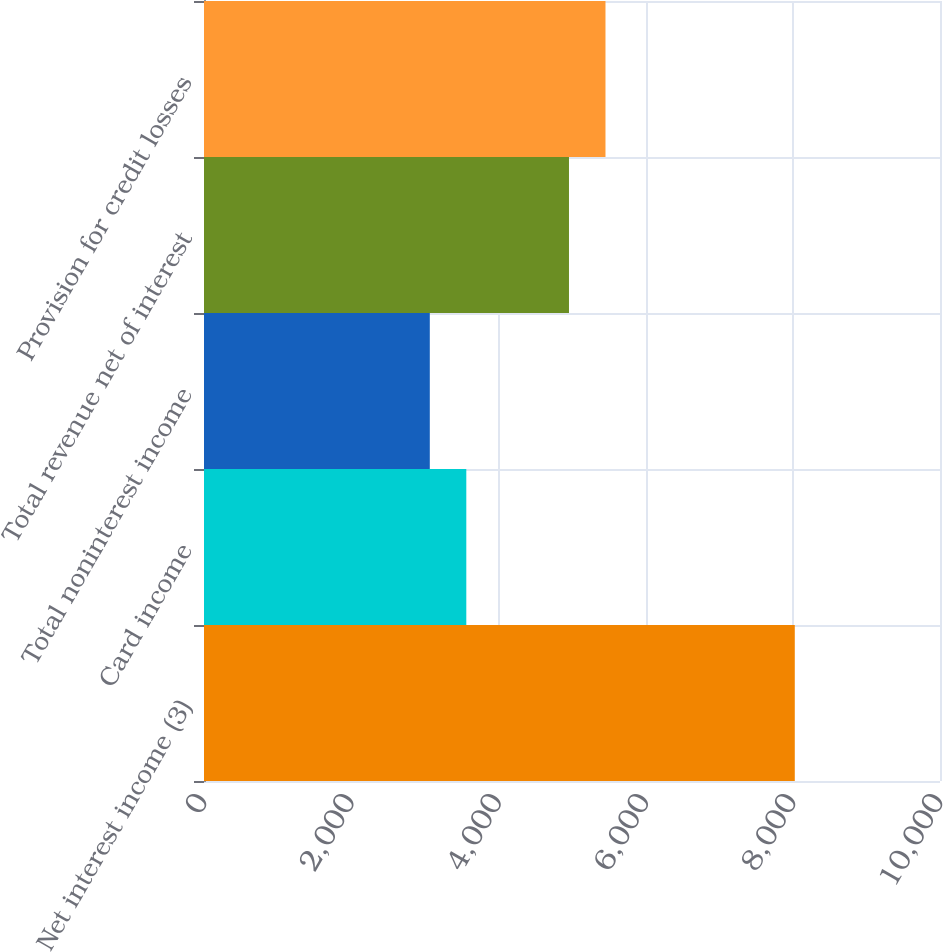Convert chart to OTSL. <chart><loc_0><loc_0><loc_500><loc_500><bar_chart><fcel>Net interest income (3)<fcel>Card income<fcel>Total noninterest income<fcel>Total revenue net of interest<fcel>Provision for credit losses<nl><fcel>8027<fcel>3563.9<fcel>3068<fcel>4959<fcel>5454.9<nl></chart> 